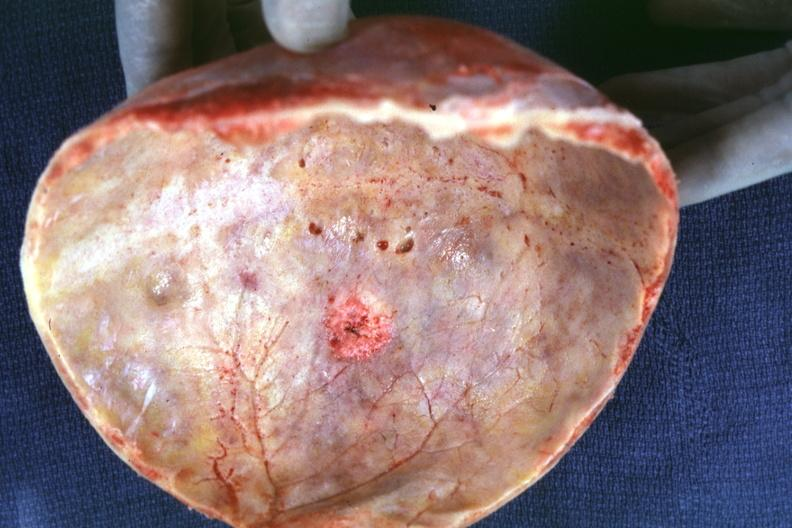does yo show skull cap with obvious metastatic lesion seen on inner table prostate primary?
Answer the question using a single word or phrase. No 